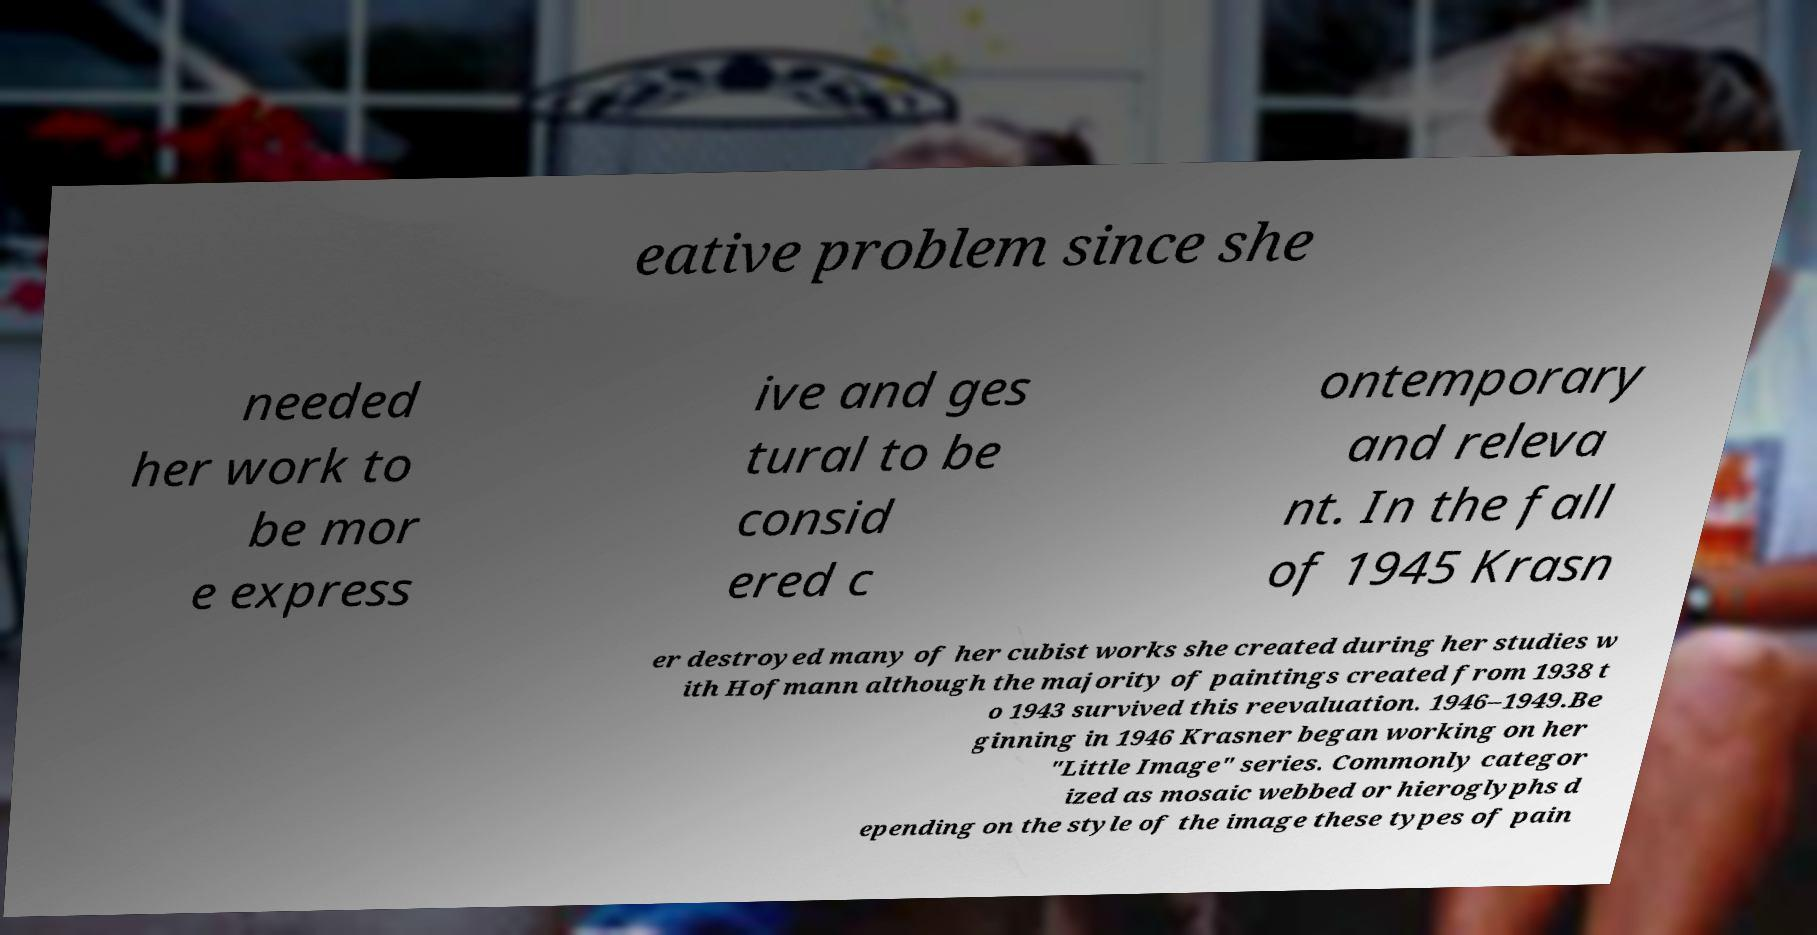For documentation purposes, I need the text within this image transcribed. Could you provide that? eative problem since she needed her work to be mor e express ive and ges tural to be consid ered c ontemporary and releva nt. In the fall of 1945 Krasn er destroyed many of her cubist works she created during her studies w ith Hofmann although the majority of paintings created from 1938 t o 1943 survived this reevaluation. 1946–1949.Be ginning in 1946 Krasner began working on her "Little Image" series. Commonly categor ized as mosaic webbed or hieroglyphs d epending on the style of the image these types of pain 